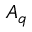Convert formula to latex. <formula><loc_0><loc_0><loc_500><loc_500>A _ { \mathfrak { q } }</formula> 